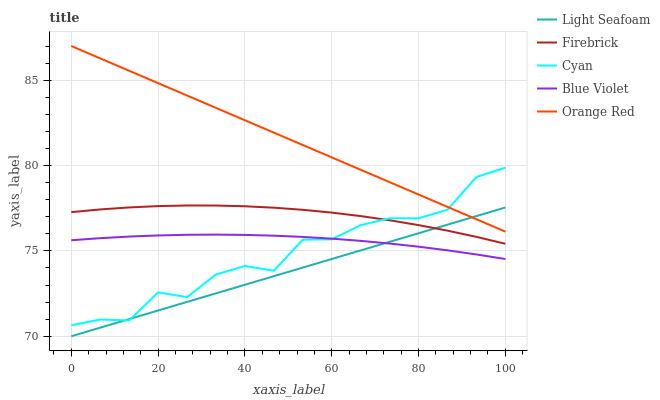Does Light Seafoam have the minimum area under the curve?
Answer yes or no. Yes. Does Orange Red have the maximum area under the curve?
Answer yes or no. Yes. Does Firebrick have the minimum area under the curve?
Answer yes or no. No. Does Firebrick have the maximum area under the curve?
Answer yes or no. No. Is Orange Red the smoothest?
Answer yes or no. Yes. Is Cyan the roughest?
Answer yes or no. Yes. Is Firebrick the smoothest?
Answer yes or no. No. Is Firebrick the roughest?
Answer yes or no. No. Does Light Seafoam have the lowest value?
Answer yes or no. Yes. Does Firebrick have the lowest value?
Answer yes or no. No. Does Orange Red have the highest value?
Answer yes or no. Yes. Does Firebrick have the highest value?
Answer yes or no. No. Is Firebrick less than Orange Red?
Answer yes or no. Yes. Is Firebrick greater than Blue Violet?
Answer yes or no. Yes. Does Light Seafoam intersect Blue Violet?
Answer yes or no. Yes. Is Light Seafoam less than Blue Violet?
Answer yes or no. No. Is Light Seafoam greater than Blue Violet?
Answer yes or no. No. Does Firebrick intersect Orange Red?
Answer yes or no. No. 